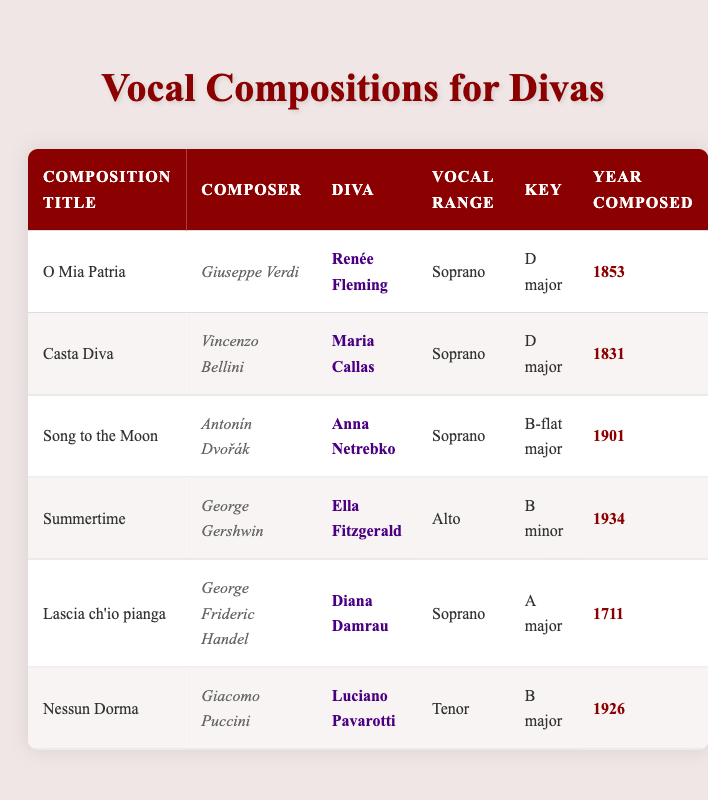What is the title of the composition composed by George Frideric Handel? The table lists all compositions, and under the "Composer" column, George Frideric Handel is associated with "Lascia ch'io pianga," which is under the "Composition Title" column.
Answer: Lascia ch'io pianga Which diva has a composition titled "Summertime"? Referring to the table, under the "Composition Title" column, "Summertime" is listed, and "Ella Fitzgerald" is associated with it under the "Diva" column.
Answer: Ella Fitzgerald What is the key of "O Mia Patria"? In the table, "O Mia Patria" is found in the "Composition Title" column, and the corresponding key from the "Key" column is "D major."
Answer: D major Is "Song to the Moon" composed by Vincenzo Bellini? Looking at the table, "Song to the Moon" corresponds to Antonín Dvořák as the composer instead of Vincenzo Bellini, thus the statement is false.
Answer: No How many compositions listed are for soprano voices? By counting the unique entries under the "Vocal Range" column labeled as "Soprano," we find "O Mia Patria," "Casta Diva," "Song to the Moon," and "Lascia ch'io pianga," making a total of four.
Answer: 4 Which diva has the earliest composition in the table? We need to sort the "Year Composed" column in ascending order to find the earliest date. The earliest entry is "Lascia ch'io pianga" from 1711, corresponding to diva Diana Damrau.
Answer: Diana Damrau What is the average year of composition for the listed works? To find the average, sum the years (1853 + 1831 + 1901 + 1934 + 1711 + 1926) for a total of 11556 and then divide by the number of compositions (6), resulting in an average year of 1926.
Answer: 1926 Does any composition for tenor have a key of B major? According to the table, the composition "Nessun Dorma," which is for tenor, indeed has a key of "B major"; therefore, the statement is true.
Answer: Yes Which compositions were written in D major? The table shows "O Mia Patria" and "Casta Diva" having the key of "D major." Therefore, there are two compositions with this key.
Answer: 2 